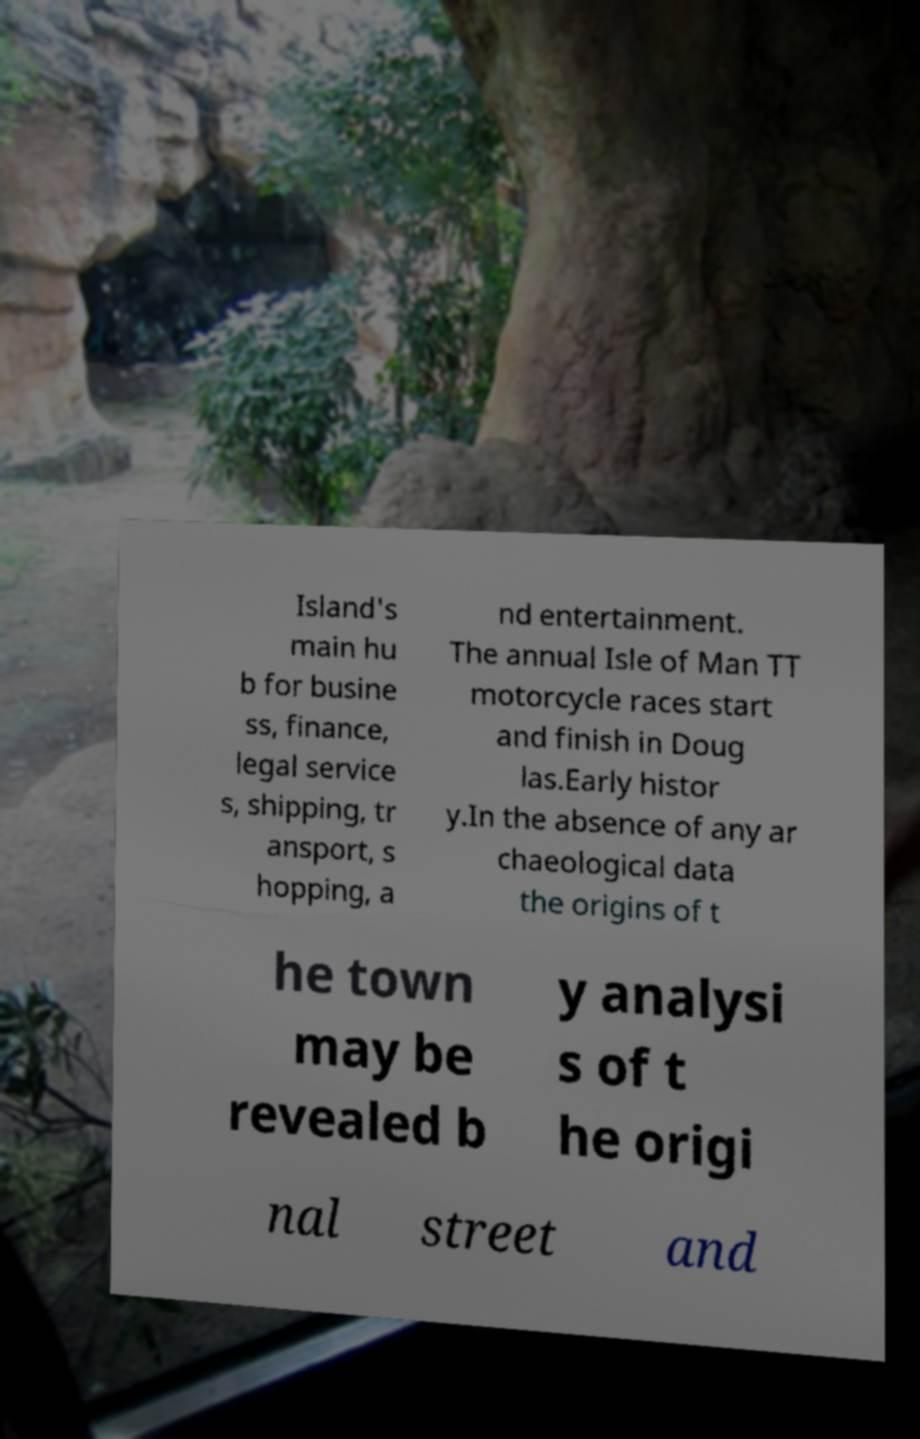Please identify and transcribe the text found in this image. Island's main hu b for busine ss, finance, legal service s, shipping, tr ansport, s hopping, a nd entertainment. The annual Isle of Man TT motorcycle races start and finish in Doug las.Early histor y.In the absence of any ar chaeological data the origins of t he town may be revealed b y analysi s of t he origi nal street and 